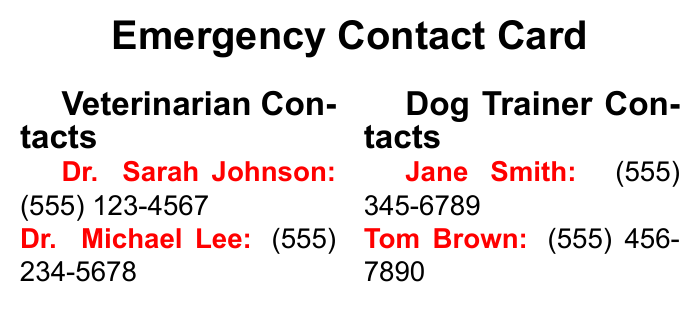What is the title of the document? The title indicates the purpose of the document, which is to provide essential contact information during emergencies.
Answer: Emergency Contact Card How many veterinarians are listed? This information can be found in the Veterinarian Contacts section of the document.
Answer: 2 What is Dr. Sarah Johnson's phone number? The phone number is explicitly provided in the Veterinarian Contacts section.
Answer: (555) 123-4567 Who is listed as the dog trainer contact? The document specifies individuals responsible for training, who are crucial for emergency situations involving dogs.
Answer: Jane Smith What should you do first in an emergency? The emergency procedures outline the steps to handle a crisis effectively and safely.
Answer: Identify emergency type What is the contact number for Poison Control? This specific number is provided in case of emergencies involving poisonous substances.
Answer: (888) 426-4435 Which emergency vet's number is provided? Important for immediate assistance, this number is crucial for urgent veterinary care.
Answer: (555) 234-5678 How many contacts are listed under Dog Trainer Contacts? This information can be derived from counting the entries under the specified section.
Answer: 2 What color is used for the headings? The headings stand out to ensure easy readability, which enhances quick access to information.
Answer: Black 